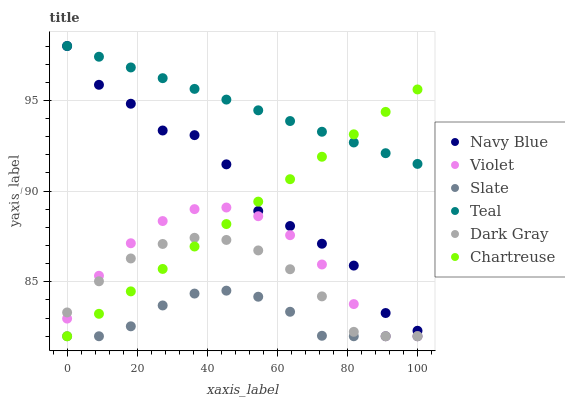Does Slate have the minimum area under the curve?
Answer yes or no. Yes. Does Teal have the maximum area under the curve?
Answer yes or no. Yes. Does Dark Gray have the minimum area under the curve?
Answer yes or no. No. Does Dark Gray have the maximum area under the curve?
Answer yes or no. No. Is Chartreuse the smoothest?
Answer yes or no. Yes. Is Navy Blue the roughest?
Answer yes or no. Yes. Is Slate the smoothest?
Answer yes or no. No. Is Slate the roughest?
Answer yes or no. No. Does Slate have the lowest value?
Answer yes or no. Yes. Does Teal have the lowest value?
Answer yes or no. No. Does Teal have the highest value?
Answer yes or no. Yes. Does Dark Gray have the highest value?
Answer yes or no. No. Is Violet less than Teal?
Answer yes or no. Yes. Is Teal greater than Slate?
Answer yes or no. Yes. Does Slate intersect Dark Gray?
Answer yes or no. Yes. Is Slate less than Dark Gray?
Answer yes or no. No. Is Slate greater than Dark Gray?
Answer yes or no. No. Does Violet intersect Teal?
Answer yes or no. No. 